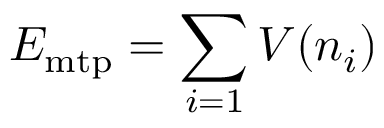<formula> <loc_0><loc_0><loc_500><loc_500>E _ { m t p } = \sum _ { i = 1 } V ( n _ { i } )</formula> 